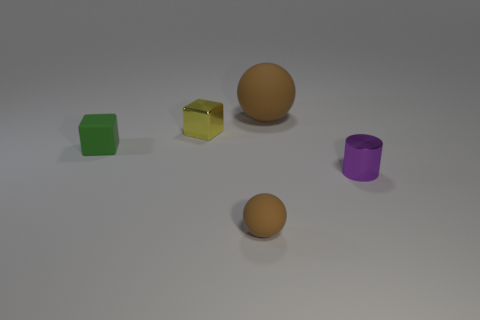Add 2 small purple shiny objects. How many objects exist? 7 Subtract all cylinders. How many objects are left? 4 Add 4 big rubber balls. How many big rubber balls are left? 5 Add 2 shiny cylinders. How many shiny cylinders exist? 3 Subtract 0 yellow spheres. How many objects are left? 5 Subtract all big matte spheres. Subtract all tiny things. How many objects are left? 0 